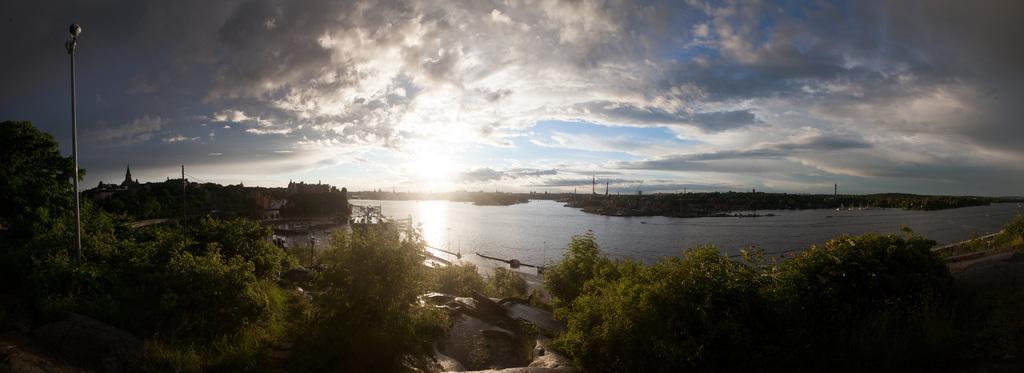How would you summarize this image in a sentence or two? In this image, we can see trees, poles and at the top, there are clouds in the sky and at the bottom, there is water. 